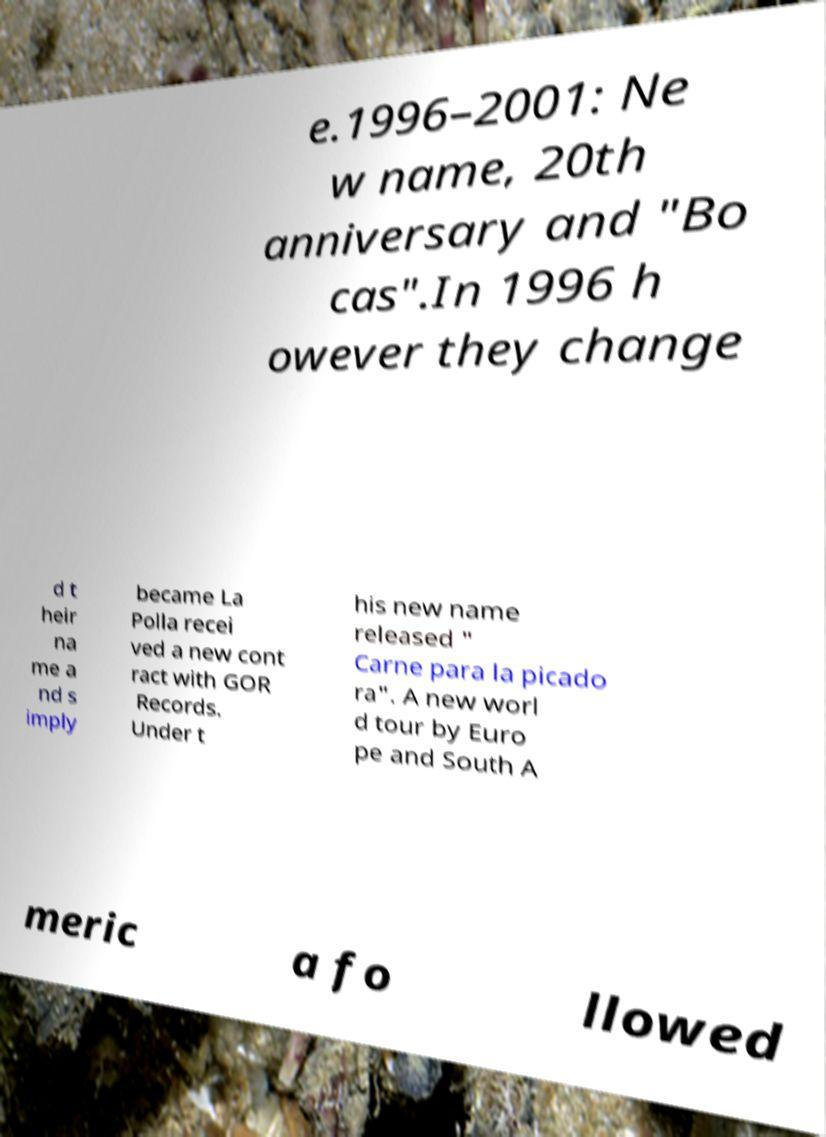Please identify and transcribe the text found in this image. e.1996–2001: Ne w name, 20th anniversary and "Bo cas".In 1996 h owever they change d t heir na me a nd s imply became La Polla recei ved a new cont ract with GOR Records. Under t his new name released " Carne para la picado ra". A new worl d tour by Euro pe and South A meric a fo llowed 